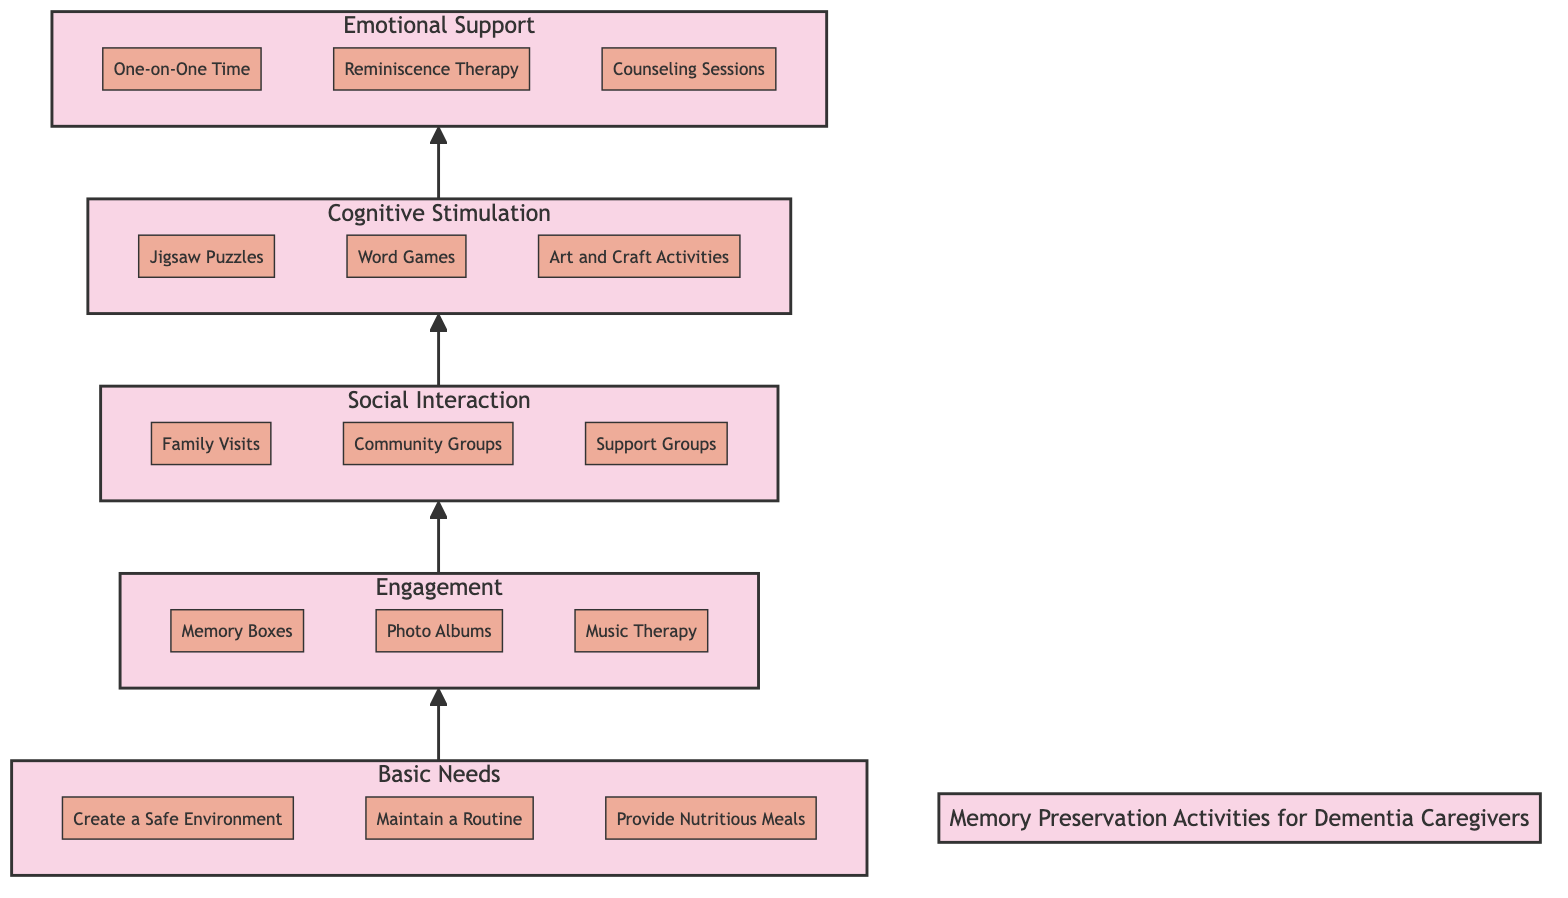What are the three elements under Basic Needs? The Basic Needs level consists of three specific actions: 'Create a Safe Environment', 'Maintain a Routine', and 'Provide Nutritious Meals'. These are visually represented under the Basic Needs node in the diagram.
Answer: Create a Safe Environment, Maintain a Routine, Provide Nutritious Meals How many levels are in this flow chart? The flow chart consists of five hierarchical levels, starting from Basic Needs at the bottom to Emotional Support at the top. Each level addresses various aspects of Memory Preservation Activities.
Answer: 5 What is the relationship between Engagement and Cognitive Stimulation? Engagement directly leads to Cognitive Stimulation, indicating that activities related to Engagement are foundational for moving up to Cognitive Stimulation. This is shown by the upward arrow connecting the two levels in the flow chart.
Answer: Engagement leads to Cognitive Stimulation Which element is listed first under Social Interaction? The first element under Social Interaction is 'Family Visits', which is positioned at the top of the Social Interaction subgraph in the diagram.
Answer: Family Visits Which two levels are directly connected? The levels that are directly connected in the flow chart are Basic Needs and Engagement, as evidenced by the upward arrow pointing from Basic Needs to Engagement.
Answer: Basic Needs and Engagement Which activity is associated with Emotional Support? Three activities are listed under Emotional Support, with one being 'One-on-One Time'. This element emphasizes personal interaction as a key activity in the Emotional Support level.
Answer: One-on-One Time What is the progression from Basic Needs to Emotional Support? The progression from Basic Needs at the bottom moves upward through Engagement and Social Interaction, culminating in Emotional Support at the top, indicating that each level builds upon the previous one.
Answer: Basic Needs → Engagement → Social Interaction → Cognitive Stimulation → Emotional Support What type of activities fall under Cognitive Stimulation? The activities listed under Cognitive Stimulation include 'Jigsaw Puzzles', 'Word Games', and 'Art and Craft Activities', which are aimed at enhancing cognitive functions.
Answer: Jigsaw Puzzles, Word Games, Art and Craft Activities 